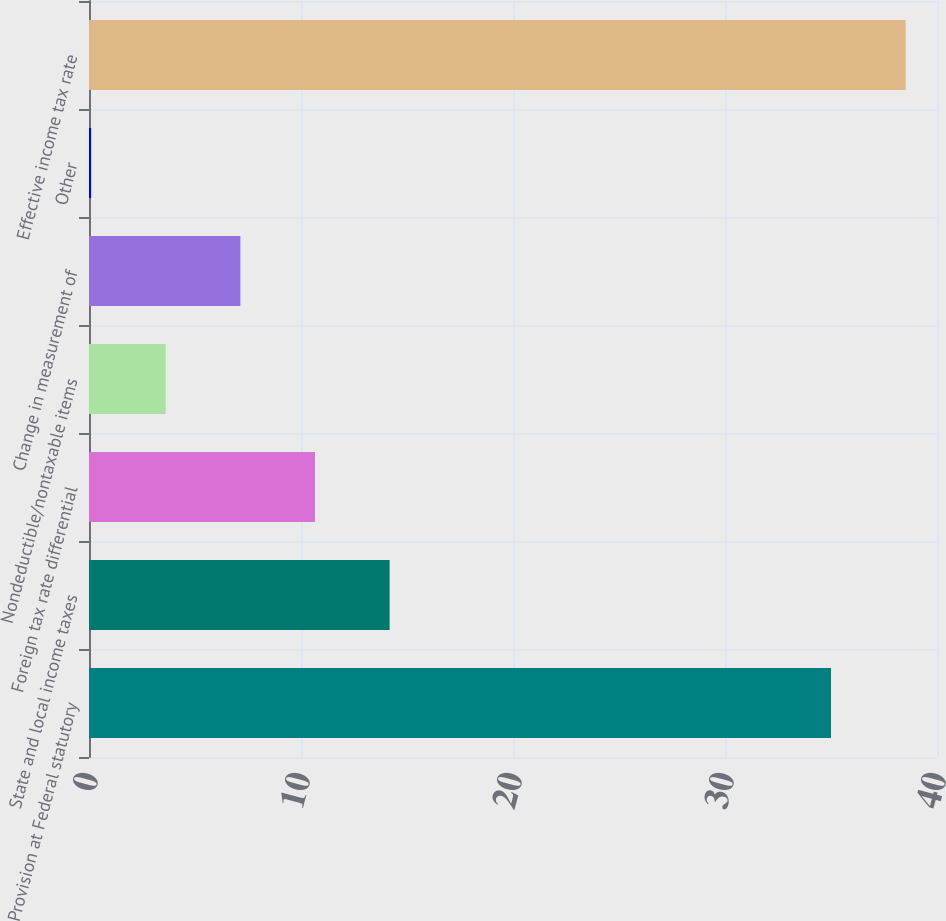Convert chart to OTSL. <chart><loc_0><loc_0><loc_500><loc_500><bar_chart><fcel>Provision at Federal statutory<fcel>State and local income taxes<fcel>Foreign tax rate differential<fcel>Nondeductible/nontaxable items<fcel>Change in measurement of<fcel>Other<fcel>Effective income tax rate<nl><fcel>35<fcel>14.18<fcel>10.66<fcel>3.62<fcel>7.14<fcel>0.1<fcel>38.52<nl></chart> 